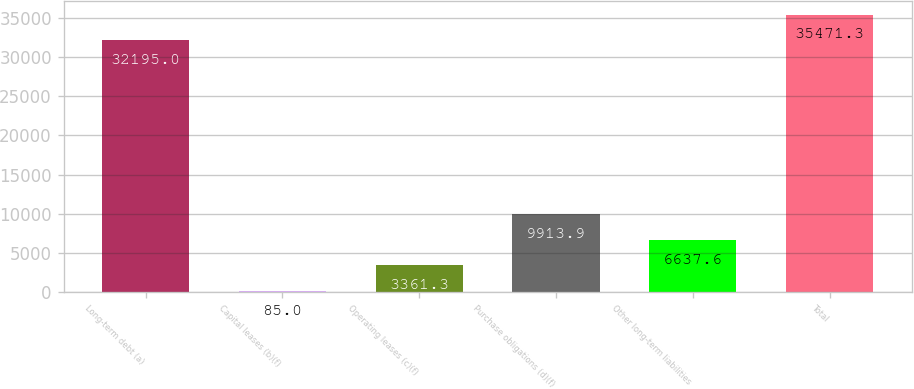Convert chart to OTSL. <chart><loc_0><loc_0><loc_500><loc_500><bar_chart><fcel>Long-term debt (a)<fcel>Capital leases (b)(f)<fcel>Operating leases (c)(f)<fcel>Purchase obligations (d)(f)<fcel>Other long-term liabilities<fcel>Total<nl><fcel>32195<fcel>85<fcel>3361.3<fcel>9913.9<fcel>6637.6<fcel>35471.3<nl></chart> 